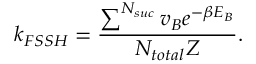Convert formula to latex. <formula><loc_0><loc_0><loc_500><loc_500>k _ { F S S H } = \frac { \sum ^ { N _ { s u c } } v _ { B } e ^ { - \beta E _ { B } } } { N _ { t o t a l } Z } .</formula> 